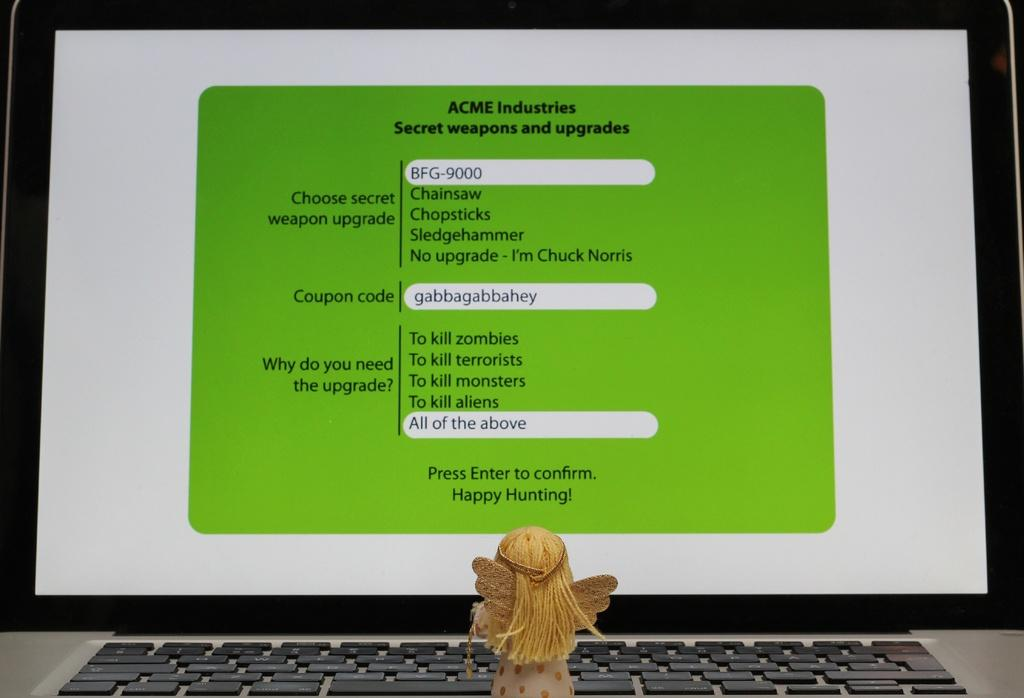<image>
Give a short and clear explanation of the subsequent image. A toy is looking at a monitor that shows a screen from ACME Industries 